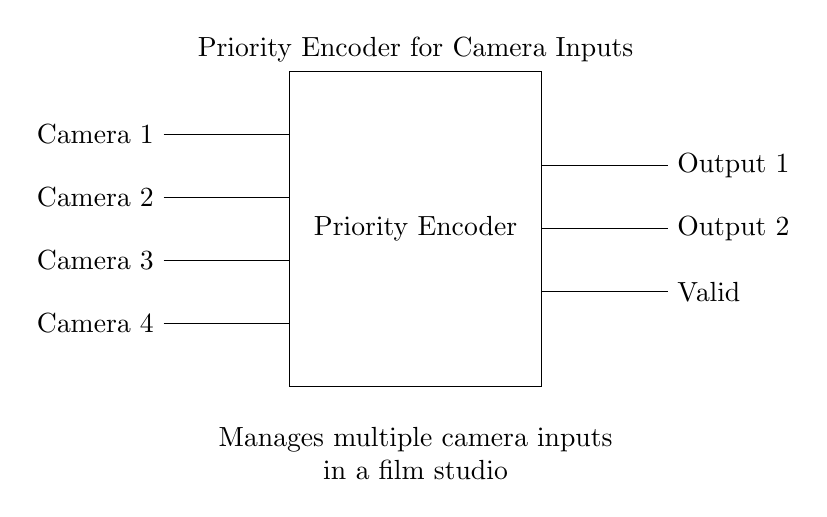What is the main component shown in the diagram? The main component is the Priority Encoder, which is depicted as a rectangle labeled "Priority Encoder." This indicates that it is the central element processing the inputs from cameras.
Answer: Priority Encoder How many input cameras are managed by the encoder? There are four input lines shown in the diagram, each representing a camera input labeled from Camera 1 to Camera 4. The connections lead into the encoder, indicating that all four inputs are being processed.
Answer: Four What do the output lines represent? The output lines labeled "Output 1," "Output 2," and "Valid" represent the results of the encoding process. "Output 1" and "Output 2" provide encoded information based on the priority of the active camera inputs, while "Valid" indicates if there is a valid input being processed.
Answer: Output 1, Output 2, Valid Which camera has the highest priority according to the input order? Camera 1 has the highest priority as it is listed first in the input sequence from the top to bottom. In a priority encoder, the order typically represents the priority level assigned to each input.
Answer: Camera 1 What does the "Valid" signal indicate? The "Valid" signal indicates whether the output from the Priority Encoder corresponds to an active input camera. If any camera is active, the signal will be high, confirming that the encoder is providing valid output.
Answer: Valid 